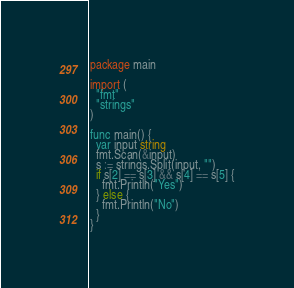<code> <loc_0><loc_0><loc_500><loc_500><_Go_>package main

import (
  "fmt"
  "strings"
)

func main() {
  var input string
  fmt.Scan(&input)
  s := strings.Split(input, "")
  if s[2] == s[3] && s[4] == s[5] {
    fmt.Println("Yes")
  } else {
    fmt.Println("No")
  }
}</code> 